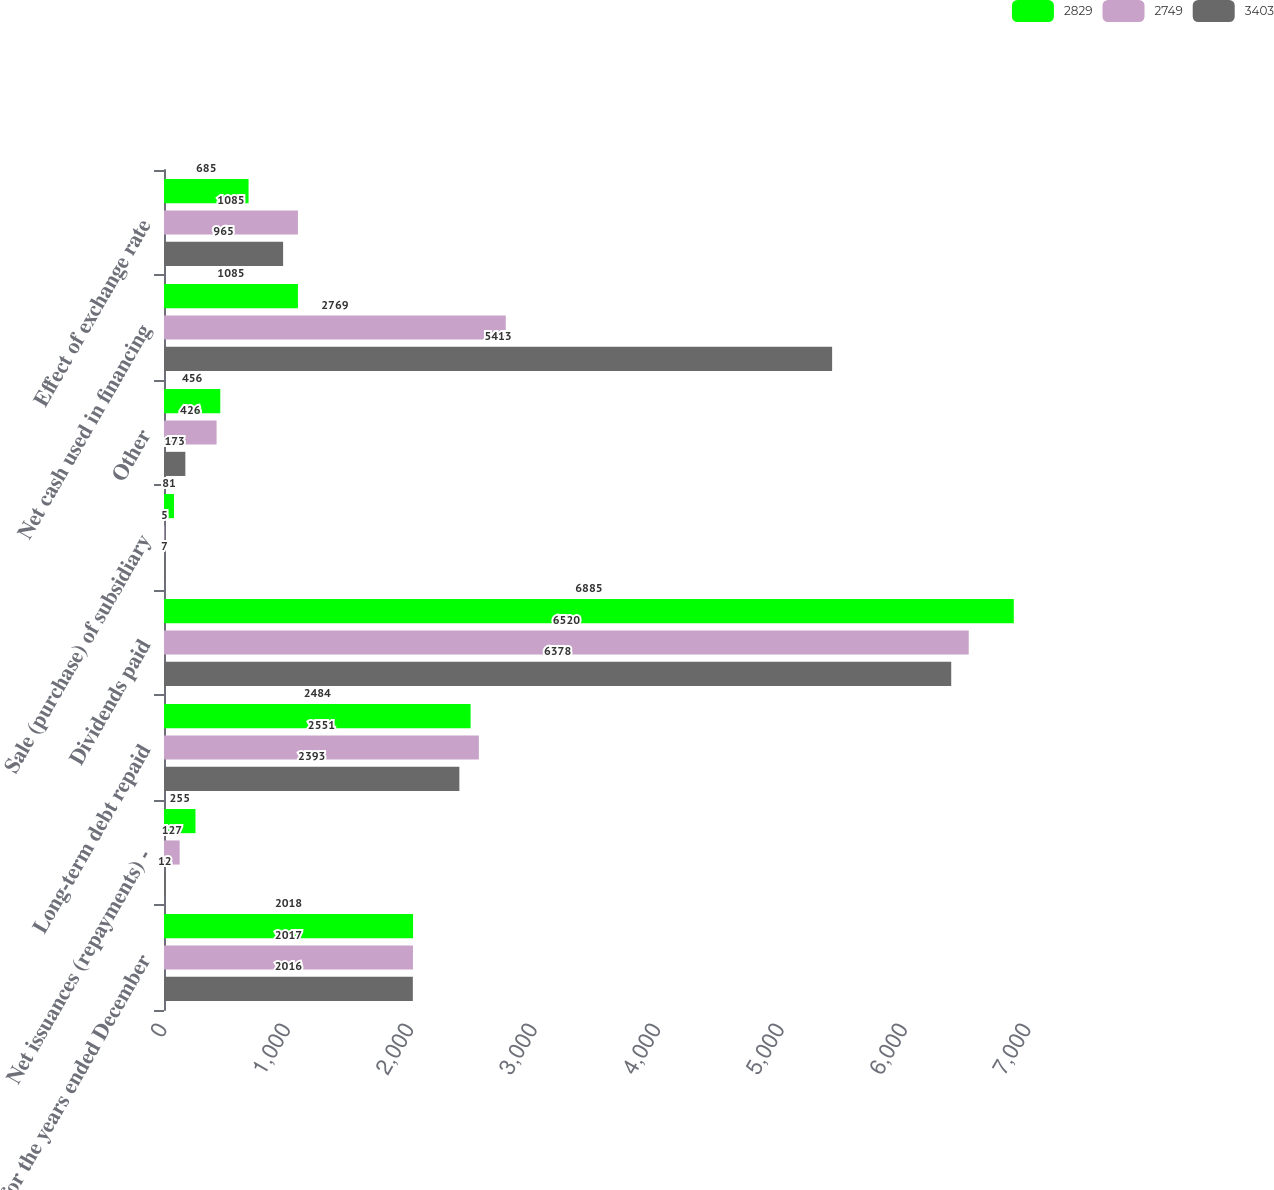<chart> <loc_0><loc_0><loc_500><loc_500><stacked_bar_chart><ecel><fcel>for the years ended December<fcel>Net issuances (repayments) -<fcel>Long-term debt repaid<fcel>Dividends paid<fcel>Sale (purchase) of subsidiary<fcel>Other<fcel>Net cash used in financing<fcel>Effect of exchange rate<nl><fcel>2829<fcel>2018<fcel>255<fcel>2484<fcel>6885<fcel>81<fcel>456<fcel>1085<fcel>685<nl><fcel>2749<fcel>2017<fcel>127<fcel>2551<fcel>6520<fcel>5<fcel>426<fcel>2769<fcel>1085<nl><fcel>3403<fcel>2016<fcel>12<fcel>2393<fcel>6378<fcel>7<fcel>173<fcel>5413<fcel>965<nl></chart> 